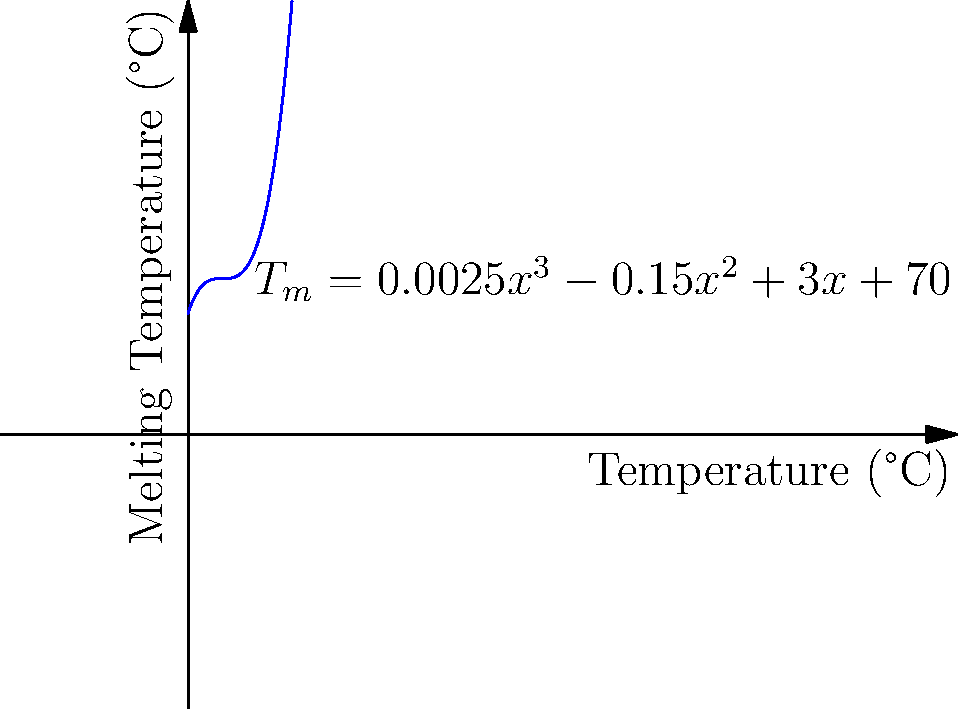Given the polynomial equation for predicting DNA melting temperature ($T_m$) based on GC content ($x$):

$$T_m = 0.0025x^3 - 0.15x^2 + 3x + 70$$

Where $T_m$ is in °C and $x$ is the percentage of GC content (0-100%).

Using the graph, estimate the melting temperature for a DNA sequence with 40% GC content. Additionally, explain how you would determine the GC content that results in the maximum melting temperature using this model. To solve this problem, we'll follow these steps:

1. Estimating melting temperature for 40% GC content:
   - Locate 40 on the x-axis (Temperature °C)
   - Move vertically to the curve
   - Read the corresponding y-value (Melting Temperature °C)
   From the graph, we can estimate that for 40% GC content, the melting temperature is approximately 85°C.

2. Determining GC content for maximum melting temperature:
   To find the maximum point of the polynomial function, we need to find where its derivative equals zero. The derivative of the function is:

   $$\frac{dT_m}{dx} = 0.0075x^2 - 0.3x + 3$$

   Set this equal to zero and solve for x:

   $$0.0075x^2 - 0.3x + 3 = 0$$

   This is a quadratic equation. The solution that falls within our domain (0-100% GC content) is the GC content that produces the maximum melting temperature.

   Using the quadratic formula or a computational method, we find that the maximum occurs at approximately 53.3% GC content.

   To verify, we could plot this point on the graph or calculate the second derivative to confirm it's a maximum.
Answer: 85°C; 53.3% GC content 